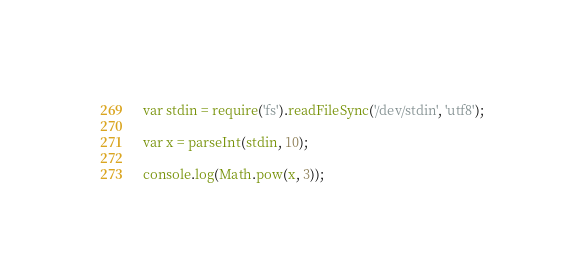Convert code to text. <code><loc_0><loc_0><loc_500><loc_500><_JavaScript_>var stdin = require('fs').readFileSync('/dev/stdin', 'utf8');

var x = parseInt(stdin, 10);

console.log(Math.pow(x, 3));</code> 